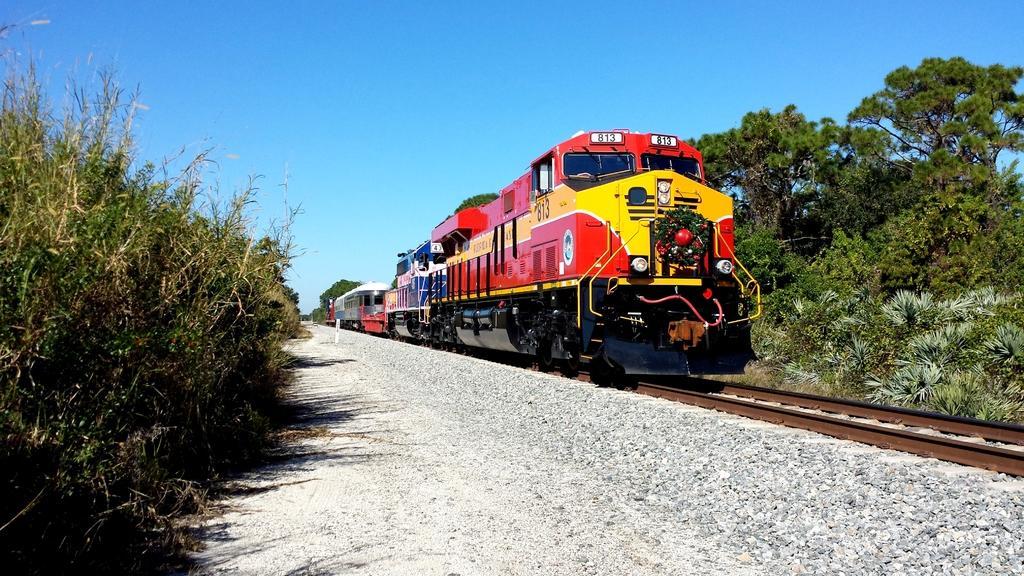Describe this image in one or two sentences. On the left side, there are plants on the ground. On the right side, there is a train on the railway track. Beside this railway track, there is a road. In the background, there are trees and plants on the ground and there is blue sky. 